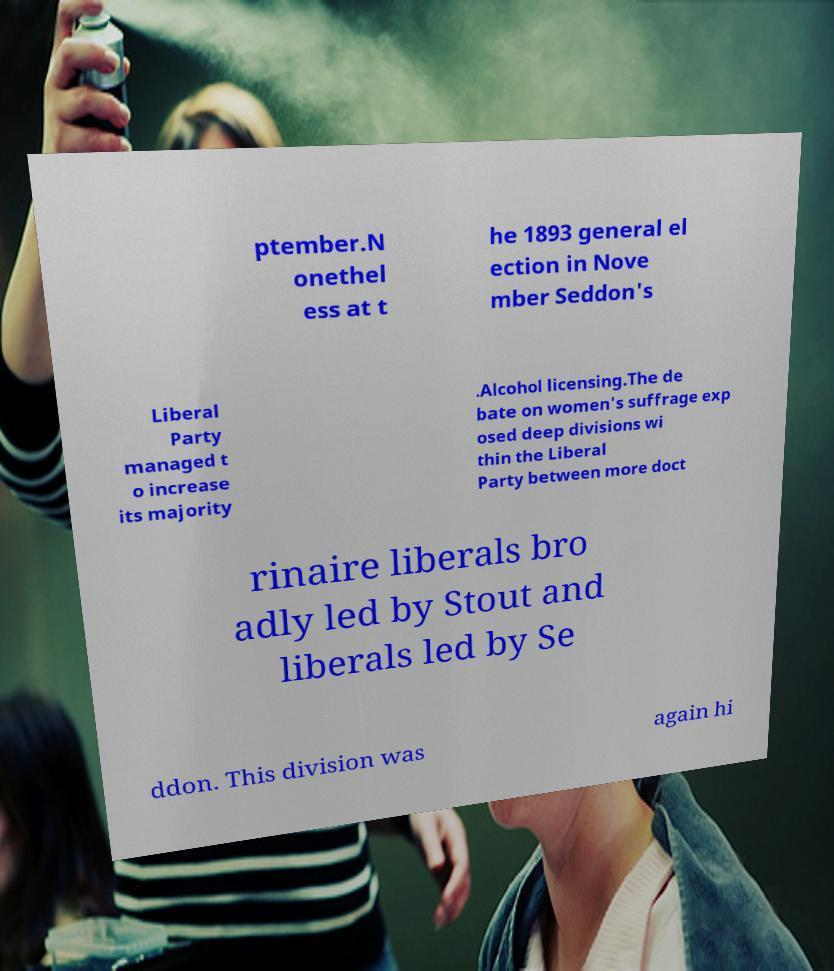Please read and relay the text visible in this image. What does it say? ptember.N onethel ess at t he 1893 general el ection in Nove mber Seddon's Liberal Party managed t o increase its majority .Alcohol licensing.The de bate on women's suffrage exp osed deep divisions wi thin the Liberal Party between more doct rinaire liberals bro adly led by Stout and liberals led by Se ddon. This division was again hi 